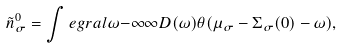Convert formula to latex. <formula><loc_0><loc_0><loc_500><loc_500>\tilde { n } ^ { 0 } _ { \sigma } = \int e g r a l { \omega } { - \infty } { \infty } D ( \omega ) \theta ( \mu _ { \sigma } - \Sigma _ { \sigma } ( 0 ) - \omega ) ,</formula> 